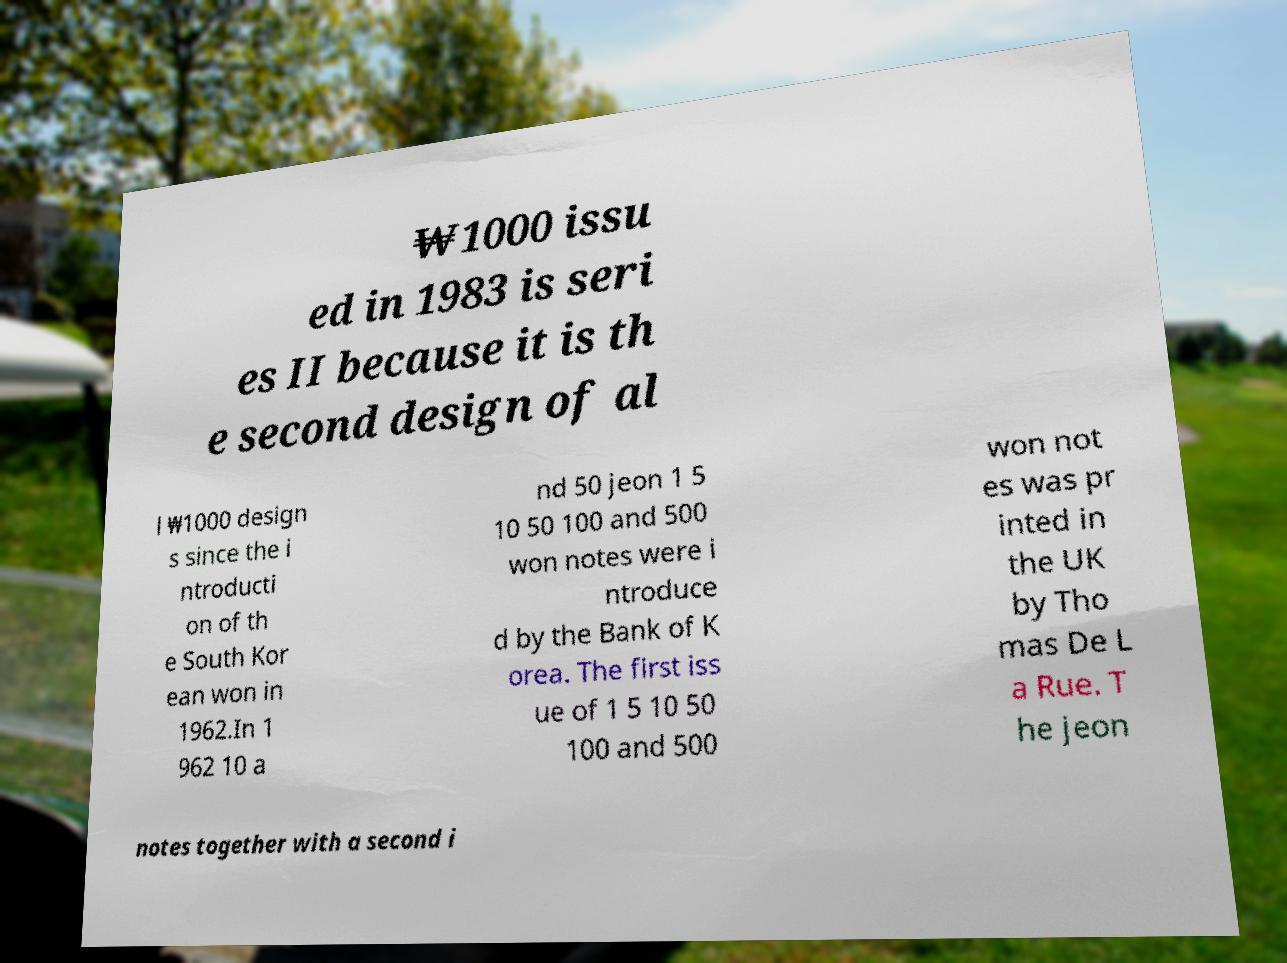For documentation purposes, I need the text within this image transcribed. Could you provide that? ₩1000 issu ed in 1983 is seri es II because it is th e second design of al l ₩1000 design s since the i ntroducti on of th e South Kor ean won in 1962.In 1 962 10 a nd 50 jeon 1 5 10 50 100 and 500 won notes were i ntroduce d by the Bank of K orea. The first iss ue of 1 5 10 50 100 and 500 won not es was pr inted in the UK by Tho mas De L a Rue. T he jeon notes together with a second i 